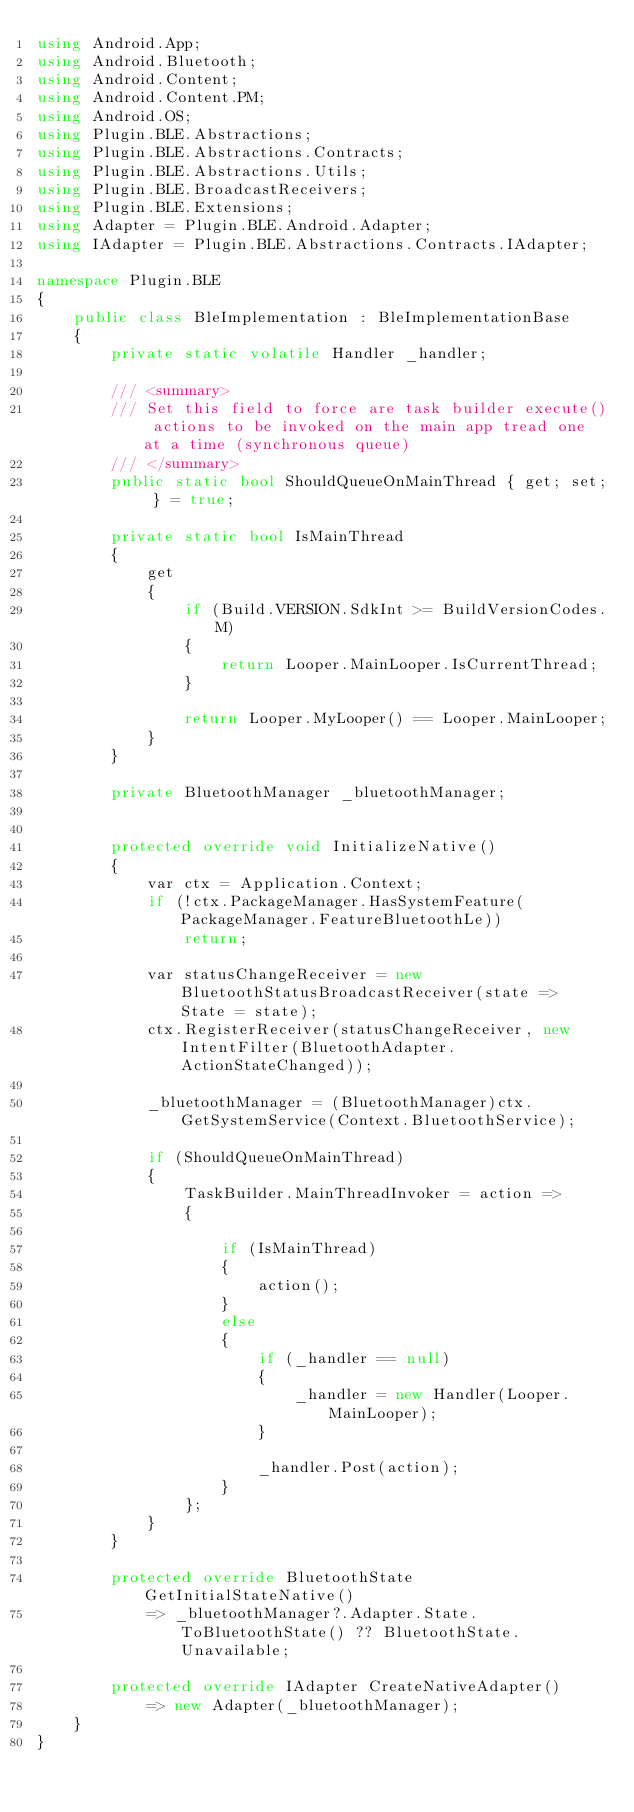<code> <loc_0><loc_0><loc_500><loc_500><_C#_>using Android.App;
using Android.Bluetooth;
using Android.Content;
using Android.Content.PM;
using Android.OS;
using Plugin.BLE.Abstractions;
using Plugin.BLE.Abstractions.Contracts;
using Plugin.BLE.Abstractions.Utils;
using Plugin.BLE.BroadcastReceivers;
using Plugin.BLE.Extensions;
using Adapter = Plugin.BLE.Android.Adapter;
using IAdapter = Plugin.BLE.Abstractions.Contracts.IAdapter;

namespace Plugin.BLE
{
    public class BleImplementation : BleImplementationBase
    {
        private static volatile Handler _handler;

        /// <summary>
        /// Set this field to force are task builder execute() actions to be invoked on the main app tread one at a time (synchronous queue)
        /// </summary>
        public static bool ShouldQueueOnMainThread { get; set; } = true;

        private static bool IsMainThread
        {
            get
            {
                if (Build.VERSION.SdkInt >= BuildVersionCodes.M)
                {
                    return Looper.MainLooper.IsCurrentThread;
                }

                return Looper.MyLooper() == Looper.MainLooper;
            }
        }

        private BluetoothManager _bluetoothManager;


        protected override void InitializeNative()
        {
            var ctx = Application.Context;
            if (!ctx.PackageManager.HasSystemFeature(PackageManager.FeatureBluetoothLe))
                return;

            var statusChangeReceiver = new BluetoothStatusBroadcastReceiver(state => State = state);
            ctx.RegisterReceiver(statusChangeReceiver, new IntentFilter(BluetoothAdapter.ActionStateChanged));

            _bluetoothManager = (BluetoothManager)ctx.GetSystemService(Context.BluetoothService);

            if (ShouldQueueOnMainThread)
            {
                TaskBuilder.MainThreadInvoker = action =>
                {

                    if (IsMainThread)
                    {
                        action();
                    }
                    else
                    {
                        if (_handler == null)
                        {
                            _handler = new Handler(Looper.MainLooper);
                        }

                        _handler.Post(action);
                    }
                };
            }
        }

        protected override BluetoothState GetInitialStateNative()
            => _bluetoothManager?.Adapter.State.ToBluetoothState() ?? BluetoothState.Unavailable;

        protected override IAdapter CreateNativeAdapter()
            => new Adapter(_bluetoothManager);
    }
}</code> 